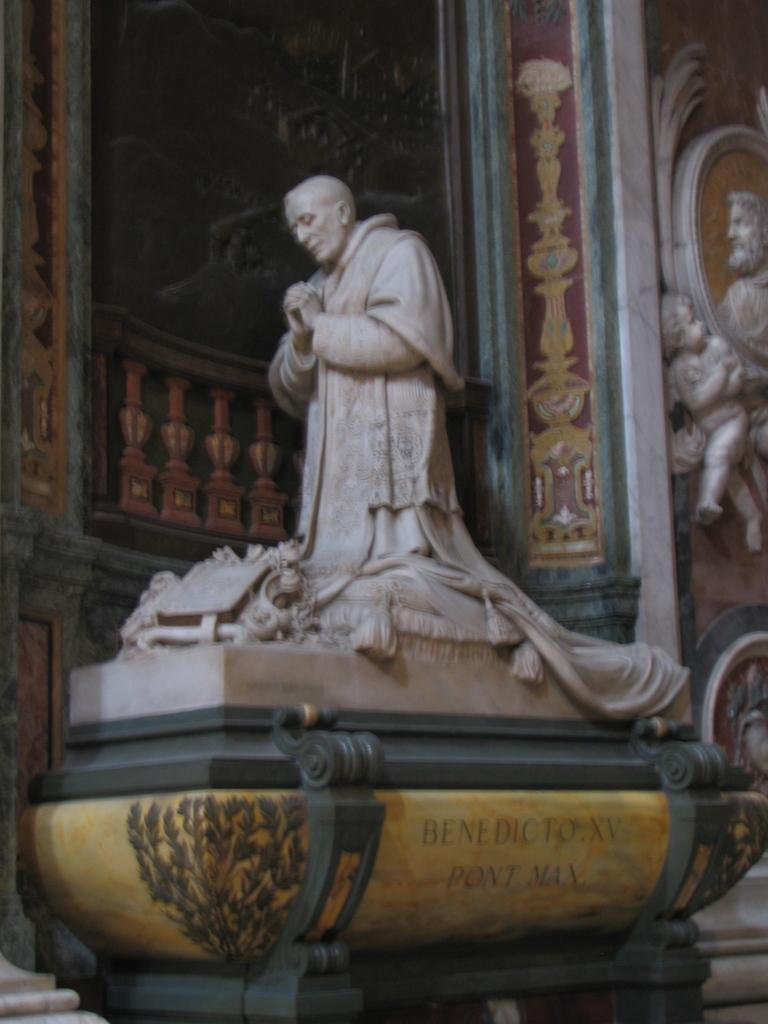What is the main subject in the middle of the image? There is a statue in the middle of the image. What other artistic elements can be seen in the image? There are sculptures in the background of the image. What type of structure is visible in the background? There is a wall visible in the background of the image. What country is mentioned in the statement made by the statue in the image? There is no statement made by the statue in the image, and therefore no country is mentioned. 